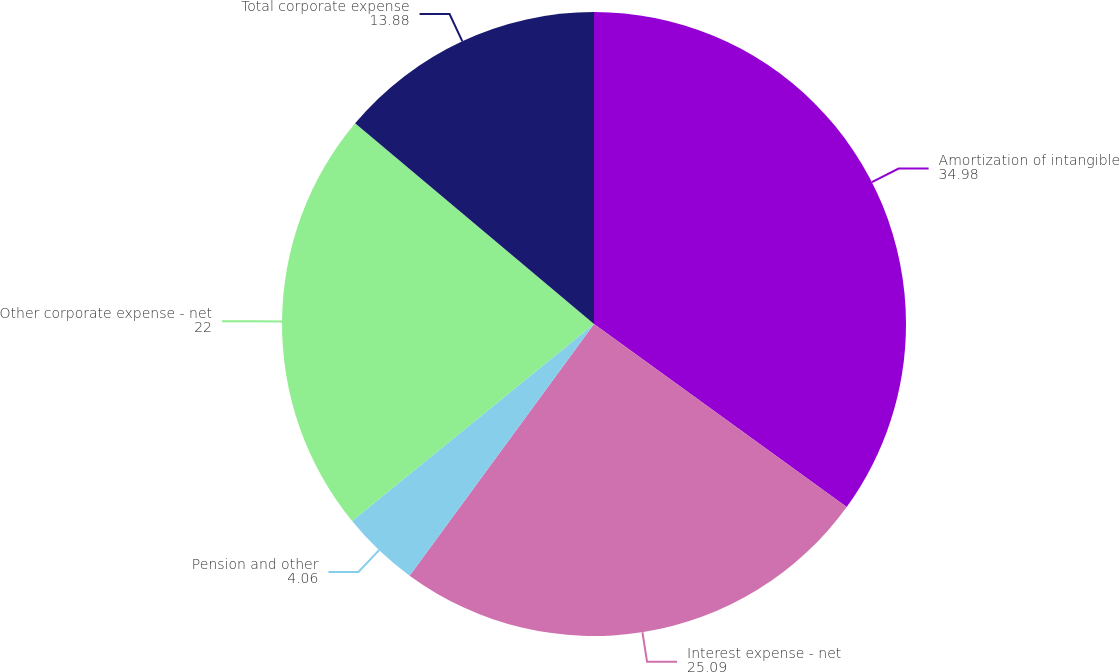Convert chart. <chart><loc_0><loc_0><loc_500><loc_500><pie_chart><fcel>Amortization of intangible<fcel>Interest expense - net<fcel>Pension and other<fcel>Other corporate expense - net<fcel>Total corporate expense<nl><fcel>34.98%<fcel>25.09%<fcel>4.06%<fcel>22.0%<fcel>13.88%<nl></chart> 